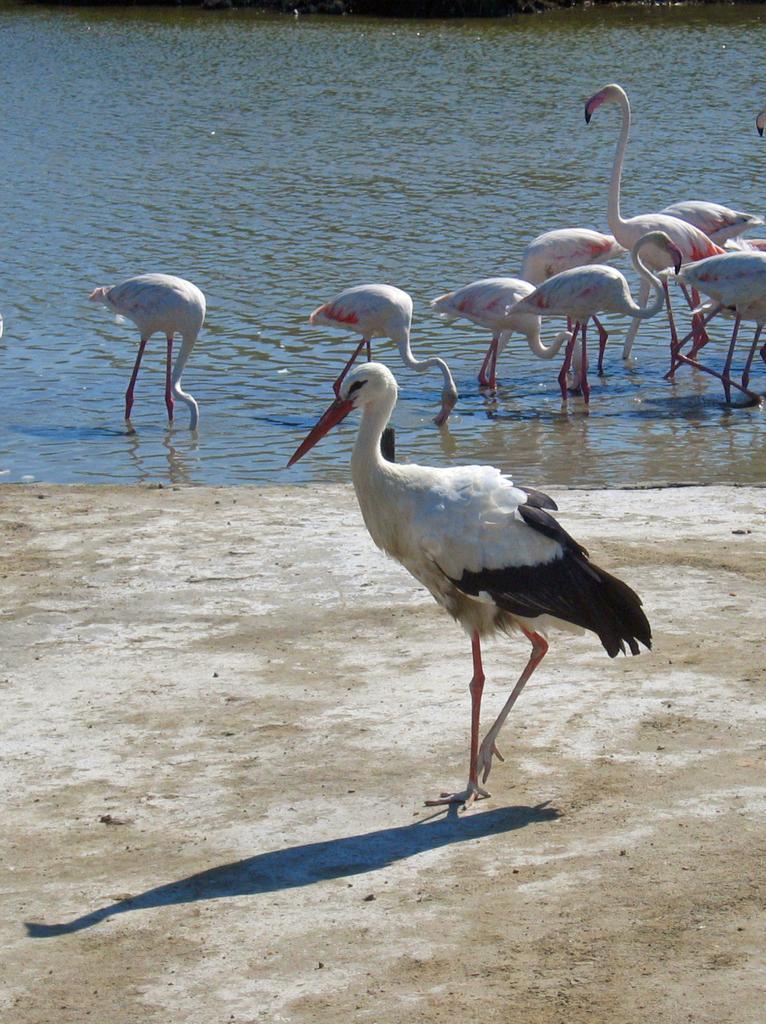Can you describe this image briefly? In this image we can see a bird is walking on the ground and we can see the shadow. In the background there are birds partially in the water. 